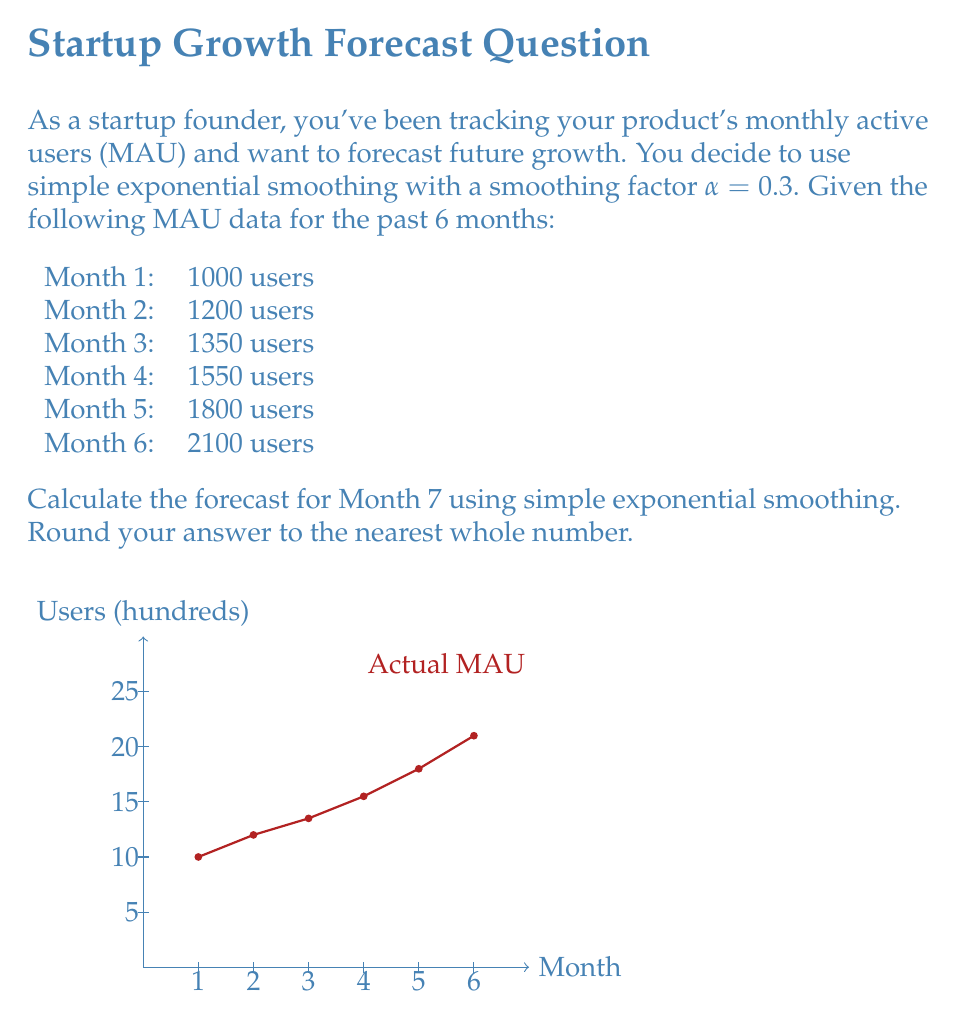Can you solve this math problem? To forecast using simple exponential smoothing, we use the formula:

$$F_{t+1} = \alpha Y_t + (1-\alpha)F_t$$

Where:
$F_{t+1}$ is the forecast for the next period
$\alpha$ is the smoothing factor (0.3 in this case)
$Y_t$ is the actual value for the current period
$F_t$ is the forecast for the current period

We start by initializing $F_1$ with the first actual value:

$F_1 = 1000$

Then we calculate each subsequent forecast:

For Month 2:
$F_2 = 0.3 * 1000 + 0.7 * 1000 = 1000$

For Month 3:
$F_3 = 0.3 * 1200 + 0.7 * 1000 = 1060$

For Month 4:
$F_4 = 0.3 * 1350 + 0.7 * 1060 = 1147$

For Month 5:
$F_5 = 0.3 * 1550 + 0.7 * 1147 = 1268.9$

For Month 6:
$F_6 = 0.3 * 1800 + 0.7 * 1268.9 = 1428.23$

Finally, for Month 7:
$F_7 = 0.3 * 2100 + 0.7 * 1428.23 = 1629.761$

Rounding to the nearest whole number, we get 1630.
Answer: 1630 users 